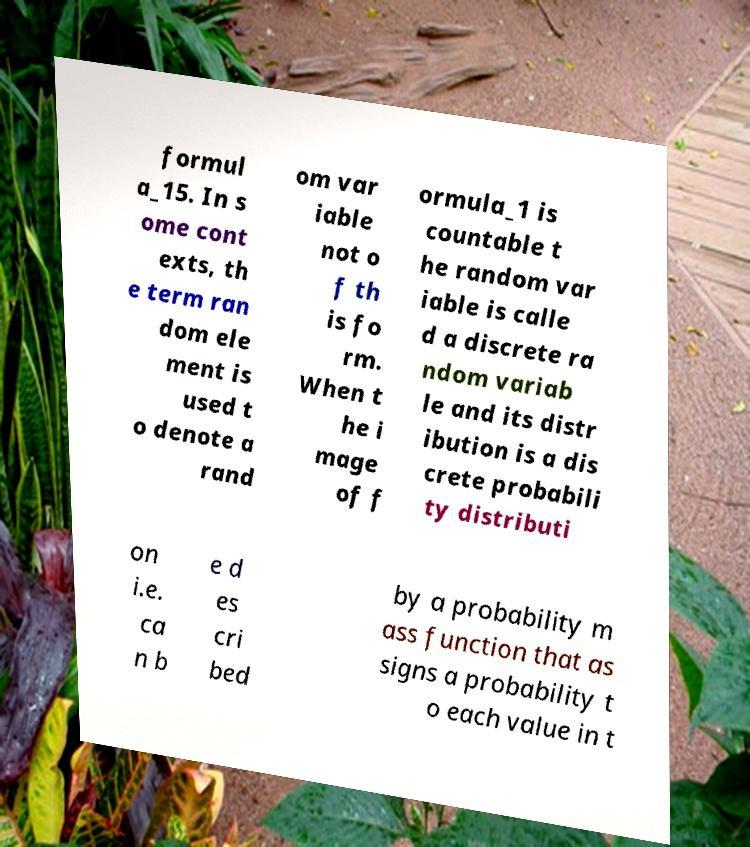Can you read and provide the text displayed in the image?This photo seems to have some interesting text. Can you extract and type it out for me? formul a_15. In s ome cont exts, th e term ran dom ele ment is used t o denote a rand om var iable not o f th is fo rm. When t he i mage of f ormula_1 is countable t he random var iable is calle d a discrete ra ndom variab le and its distr ibution is a dis crete probabili ty distributi on i.e. ca n b e d es cri bed by a probability m ass function that as signs a probability t o each value in t 